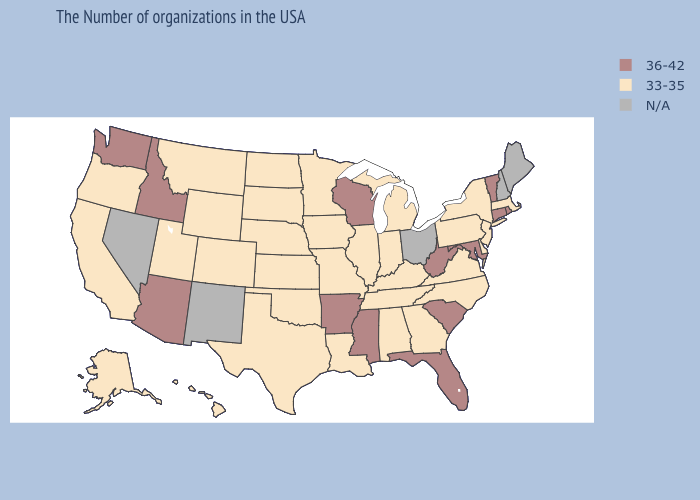How many symbols are there in the legend?
Short answer required. 3. What is the value of Texas?
Be succinct. 33-35. Name the states that have a value in the range N/A?
Quick response, please. Maine, New Hampshire, Ohio, New Mexico, Nevada. Name the states that have a value in the range 33-35?
Concise answer only. Massachusetts, New York, New Jersey, Delaware, Pennsylvania, Virginia, North Carolina, Georgia, Michigan, Kentucky, Indiana, Alabama, Tennessee, Illinois, Louisiana, Missouri, Minnesota, Iowa, Kansas, Nebraska, Oklahoma, Texas, South Dakota, North Dakota, Wyoming, Colorado, Utah, Montana, California, Oregon, Alaska, Hawaii. Name the states that have a value in the range 36-42?
Give a very brief answer. Rhode Island, Vermont, Connecticut, Maryland, South Carolina, West Virginia, Florida, Wisconsin, Mississippi, Arkansas, Arizona, Idaho, Washington. Which states hav the highest value in the West?
Answer briefly. Arizona, Idaho, Washington. Does Indiana have the highest value in the MidWest?
Be succinct. No. Name the states that have a value in the range 36-42?
Be succinct. Rhode Island, Vermont, Connecticut, Maryland, South Carolina, West Virginia, Florida, Wisconsin, Mississippi, Arkansas, Arizona, Idaho, Washington. Name the states that have a value in the range N/A?
Write a very short answer. Maine, New Hampshire, Ohio, New Mexico, Nevada. What is the lowest value in the South?
Keep it brief. 33-35. What is the lowest value in states that border Connecticut?
Be succinct. 33-35. Which states have the lowest value in the MidWest?
Write a very short answer. Michigan, Indiana, Illinois, Missouri, Minnesota, Iowa, Kansas, Nebraska, South Dakota, North Dakota. What is the value of Maryland?
Short answer required. 36-42. What is the value of North Carolina?
Answer briefly. 33-35. How many symbols are there in the legend?
Keep it brief. 3. 